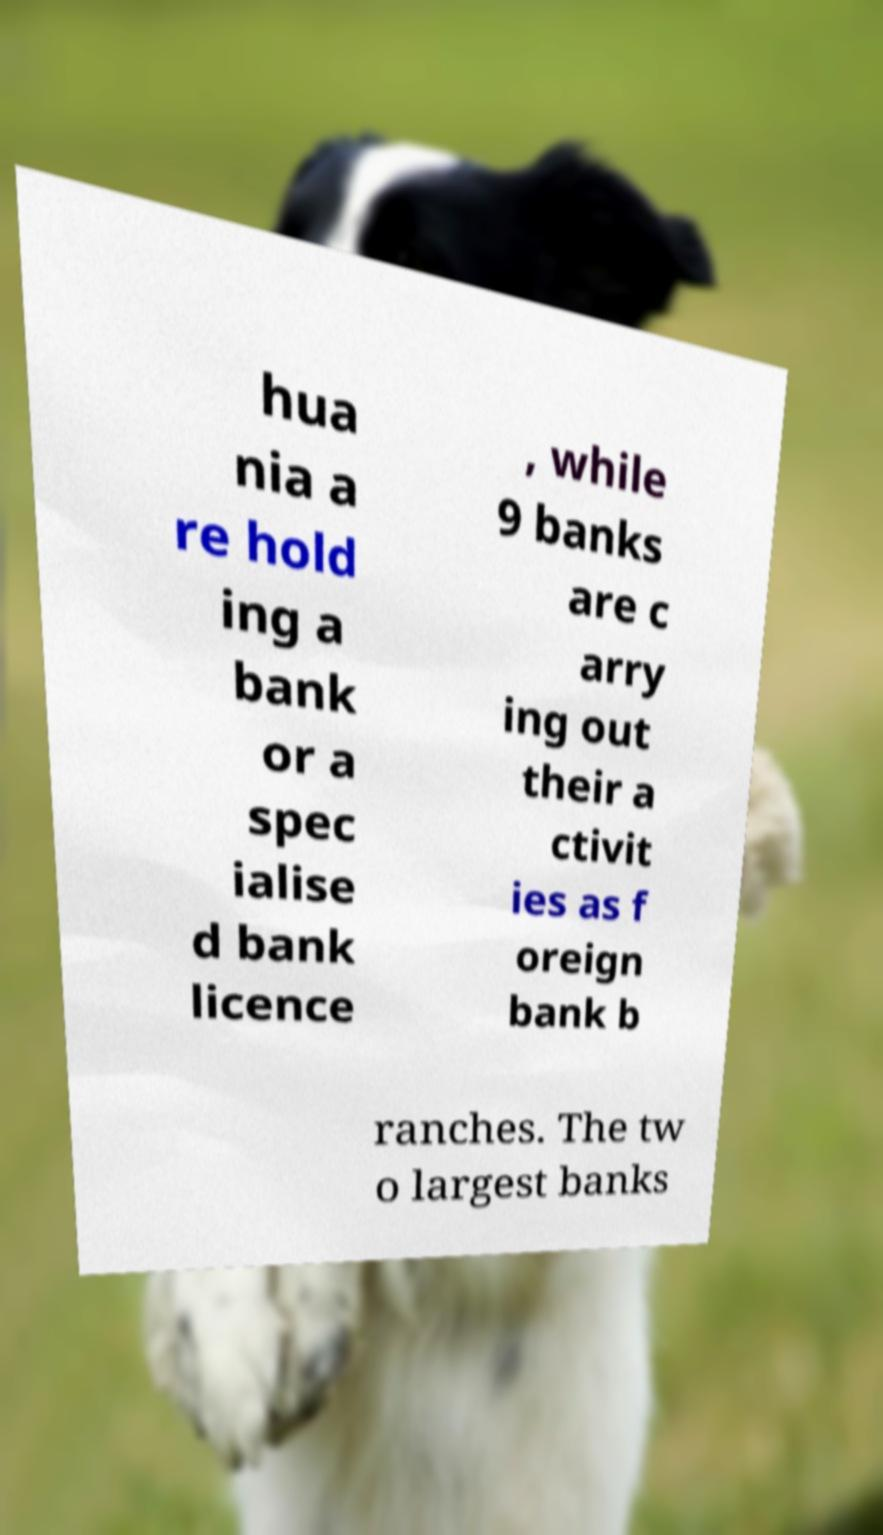Could you extract and type out the text from this image? hua nia a re hold ing a bank or a spec ialise d bank licence , while 9 banks are c arry ing out their a ctivit ies as f oreign bank b ranches. The tw o largest banks 